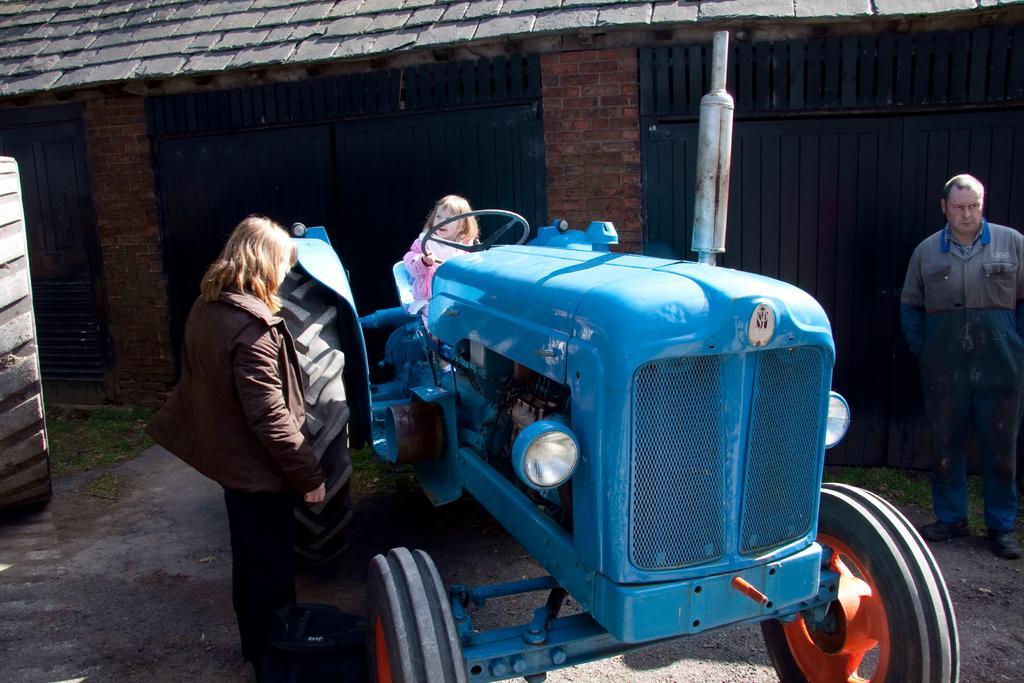How would you summarize this image in a sentence or two? In this image I can see the vehicle and I can also see the person sitting in the vehicle and I can see two persons standing. In the background I can see the railing and the wall is in brown color. 